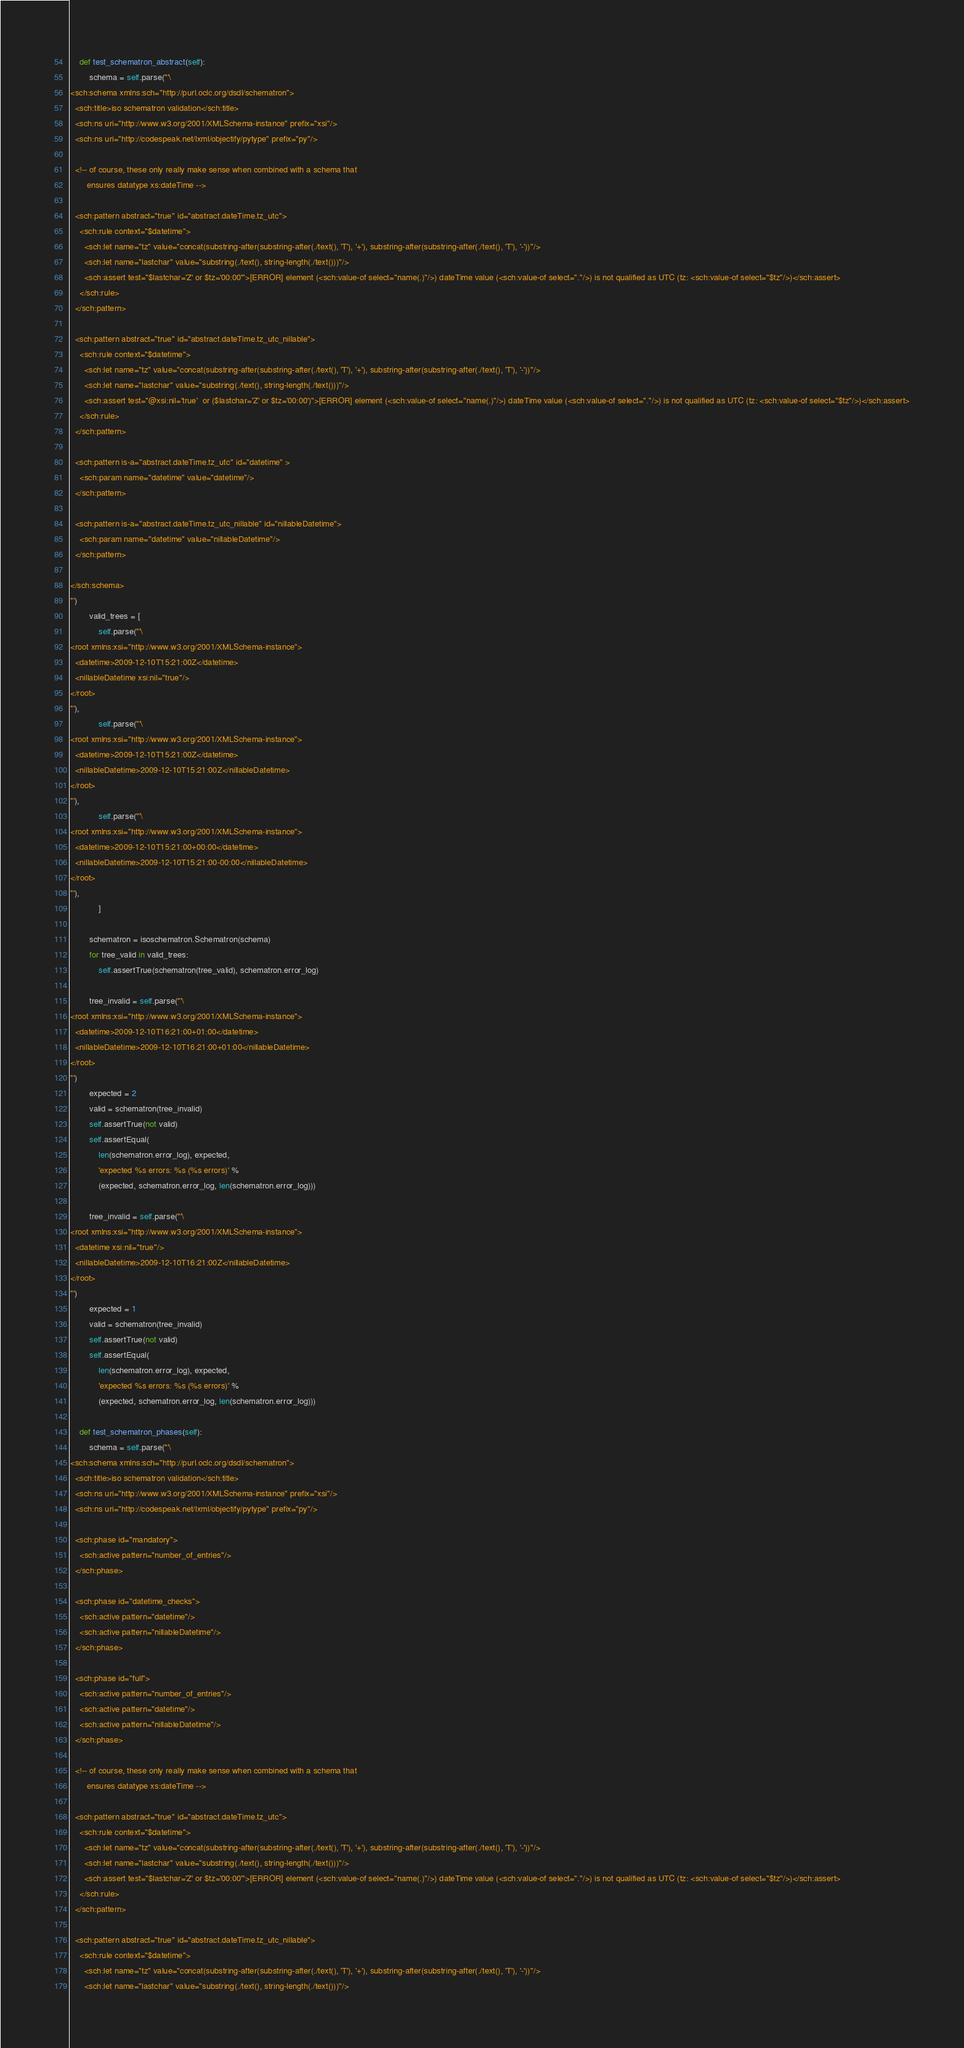<code> <loc_0><loc_0><loc_500><loc_500><_Python_>
    def test_schematron_abstract(self):
        schema = self.parse('''\
<sch:schema xmlns:sch="http://purl.oclc.org/dsdl/schematron">
  <sch:title>iso schematron validation</sch:title>
  <sch:ns uri="http://www.w3.org/2001/XMLSchema-instance" prefix="xsi"/>
  <sch:ns uri="http://codespeak.net/lxml/objectify/pytype" prefix="py"/>

  <!-- of course, these only really make sense when combined with a schema that
       ensures datatype xs:dateTime -->

  <sch:pattern abstract="true" id="abstract.dateTime.tz_utc">
    <sch:rule context="$datetime">
      <sch:let name="tz" value="concat(substring-after(substring-after(./text(), 'T'), '+'), substring-after(substring-after(./text(), 'T'), '-'))"/>
      <sch:let name="lastchar" value="substring(./text(), string-length(./text()))"/>
      <sch:assert test="$lastchar='Z' or $tz='00:00'">[ERROR] element (<sch:value-of select="name(.)"/>) dateTime value (<sch:value-of select="."/>) is not qualified as UTC (tz: <sch:value-of select="$tz"/>)</sch:assert>
    </sch:rule>
  </sch:pattern>

  <sch:pattern abstract="true" id="abstract.dateTime.tz_utc_nillable">
    <sch:rule context="$datetime">
      <sch:let name="tz" value="concat(substring-after(substring-after(./text(), 'T'), '+'), substring-after(substring-after(./text(), 'T'), '-'))"/>
      <sch:let name="lastchar" value="substring(./text(), string-length(./text()))"/>
      <sch:assert test="@xsi:nil='true'  or ($lastchar='Z' or $tz='00:00')">[ERROR] element (<sch:value-of select="name(.)"/>) dateTime value (<sch:value-of select="."/>) is not qualified as UTC (tz: <sch:value-of select="$tz"/>)</sch:assert>
    </sch:rule>
  </sch:pattern>

  <sch:pattern is-a="abstract.dateTime.tz_utc" id="datetime" >
    <sch:param name="datetime" value="datetime"/>
  </sch:pattern>

  <sch:pattern is-a="abstract.dateTime.tz_utc_nillable" id="nillableDatetime">
    <sch:param name="datetime" value="nillableDatetime"/>
  </sch:pattern>

</sch:schema>
''')
        valid_trees = [
            self.parse('''\
<root xmlns:xsi="http://www.w3.org/2001/XMLSchema-instance">
  <datetime>2009-12-10T15:21:00Z</datetime>
  <nillableDatetime xsi:nil="true"/>
</root>
'''),
            self.parse('''\
<root xmlns:xsi="http://www.w3.org/2001/XMLSchema-instance">
  <datetime>2009-12-10T15:21:00Z</datetime>
  <nillableDatetime>2009-12-10T15:21:00Z</nillableDatetime>
</root>
'''),
            self.parse('''\
<root xmlns:xsi="http://www.w3.org/2001/XMLSchema-instance">
  <datetime>2009-12-10T15:21:00+00:00</datetime>
  <nillableDatetime>2009-12-10T15:21:00-00:00</nillableDatetime>
</root>
'''),
            ]

        schematron = isoschematron.Schematron(schema)
        for tree_valid in valid_trees:
            self.assertTrue(schematron(tree_valid), schematron.error_log)

        tree_invalid = self.parse('''\
<root xmlns:xsi="http://www.w3.org/2001/XMLSchema-instance">
  <datetime>2009-12-10T16:21:00+01:00</datetime>
  <nillableDatetime>2009-12-10T16:21:00+01:00</nillableDatetime>
</root>
''')
        expected = 2
        valid = schematron(tree_invalid)
        self.assertTrue(not valid)
        self.assertEqual(
            len(schematron.error_log), expected,
            'expected %s errors: %s (%s errors)' %
            (expected, schematron.error_log, len(schematron.error_log)))

        tree_invalid = self.parse('''\
<root xmlns:xsi="http://www.w3.org/2001/XMLSchema-instance">
  <datetime xsi:nil="true"/>
  <nillableDatetime>2009-12-10T16:21:00Z</nillableDatetime>
</root>
''')
        expected = 1
        valid = schematron(tree_invalid)
        self.assertTrue(not valid)
        self.assertEqual(
            len(schematron.error_log), expected,
            'expected %s errors: %s (%s errors)' %
            (expected, schematron.error_log, len(schematron.error_log)))

    def test_schematron_phases(self):
        schema = self.parse('''\
<sch:schema xmlns:sch="http://purl.oclc.org/dsdl/schematron">
  <sch:title>iso schematron validation</sch:title>
  <sch:ns uri="http://www.w3.org/2001/XMLSchema-instance" prefix="xsi"/>
  <sch:ns uri="http://codespeak.net/lxml/objectify/pytype" prefix="py"/>

  <sch:phase id="mandatory">
    <sch:active pattern="number_of_entries"/>
  </sch:phase>

  <sch:phase id="datetime_checks">
    <sch:active pattern="datetime"/>
    <sch:active pattern="nillableDatetime"/>
  </sch:phase>

  <sch:phase id="full">
    <sch:active pattern="number_of_entries"/>
    <sch:active pattern="datetime"/>
    <sch:active pattern="nillableDatetime"/>
  </sch:phase>

  <!-- of course, these only really make sense when combined with a schema that
       ensures datatype xs:dateTime -->

  <sch:pattern abstract="true" id="abstract.dateTime.tz_utc">
    <sch:rule context="$datetime">
      <sch:let name="tz" value="concat(substring-after(substring-after(./text(), 'T'), '+'), substring-after(substring-after(./text(), 'T'), '-'))"/>
      <sch:let name="lastchar" value="substring(./text(), string-length(./text()))"/>
      <sch:assert test="$lastchar='Z' or $tz='00:00'">[ERROR] element (<sch:value-of select="name(.)"/>) dateTime value (<sch:value-of select="."/>) is not qualified as UTC (tz: <sch:value-of select="$tz"/>)</sch:assert>
    </sch:rule>
  </sch:pattern>

  <sch:pattern abstract="true" id="abstract.dateTime.tz_utc_nillable">
    <sch:rule context="$datetime">
      <sch:let name="tz" value="concat(substring-after(substring-after(./text(), 'T'), '+'), substring-after(substring-after(./text(), 'T'), '-'))"/>
      <sch:let name="lastchar" value="substring(./text(), string-length(./text()))"/></code> 